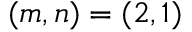Convert formula to latex. <formula><loc_0><loc_0><loc_500><loc_500>( m , n ) = ( 2 , 1 )</formula> 